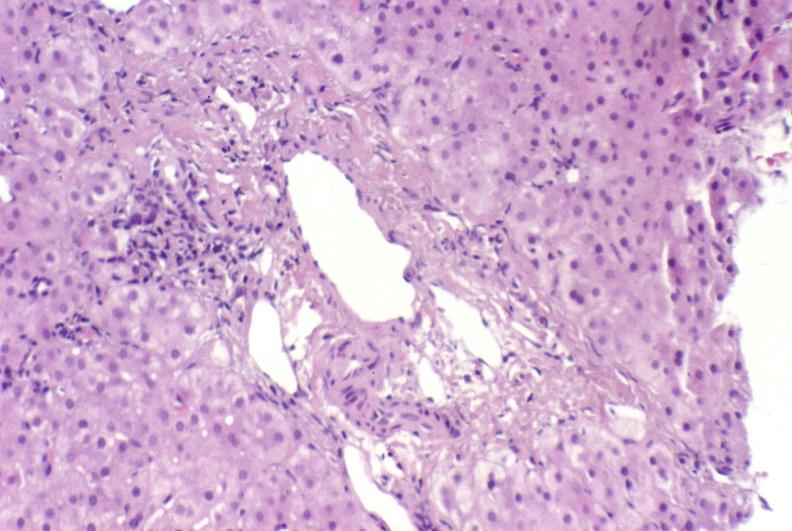s liver present?
Answer the question using a single word or phrase. Yes 